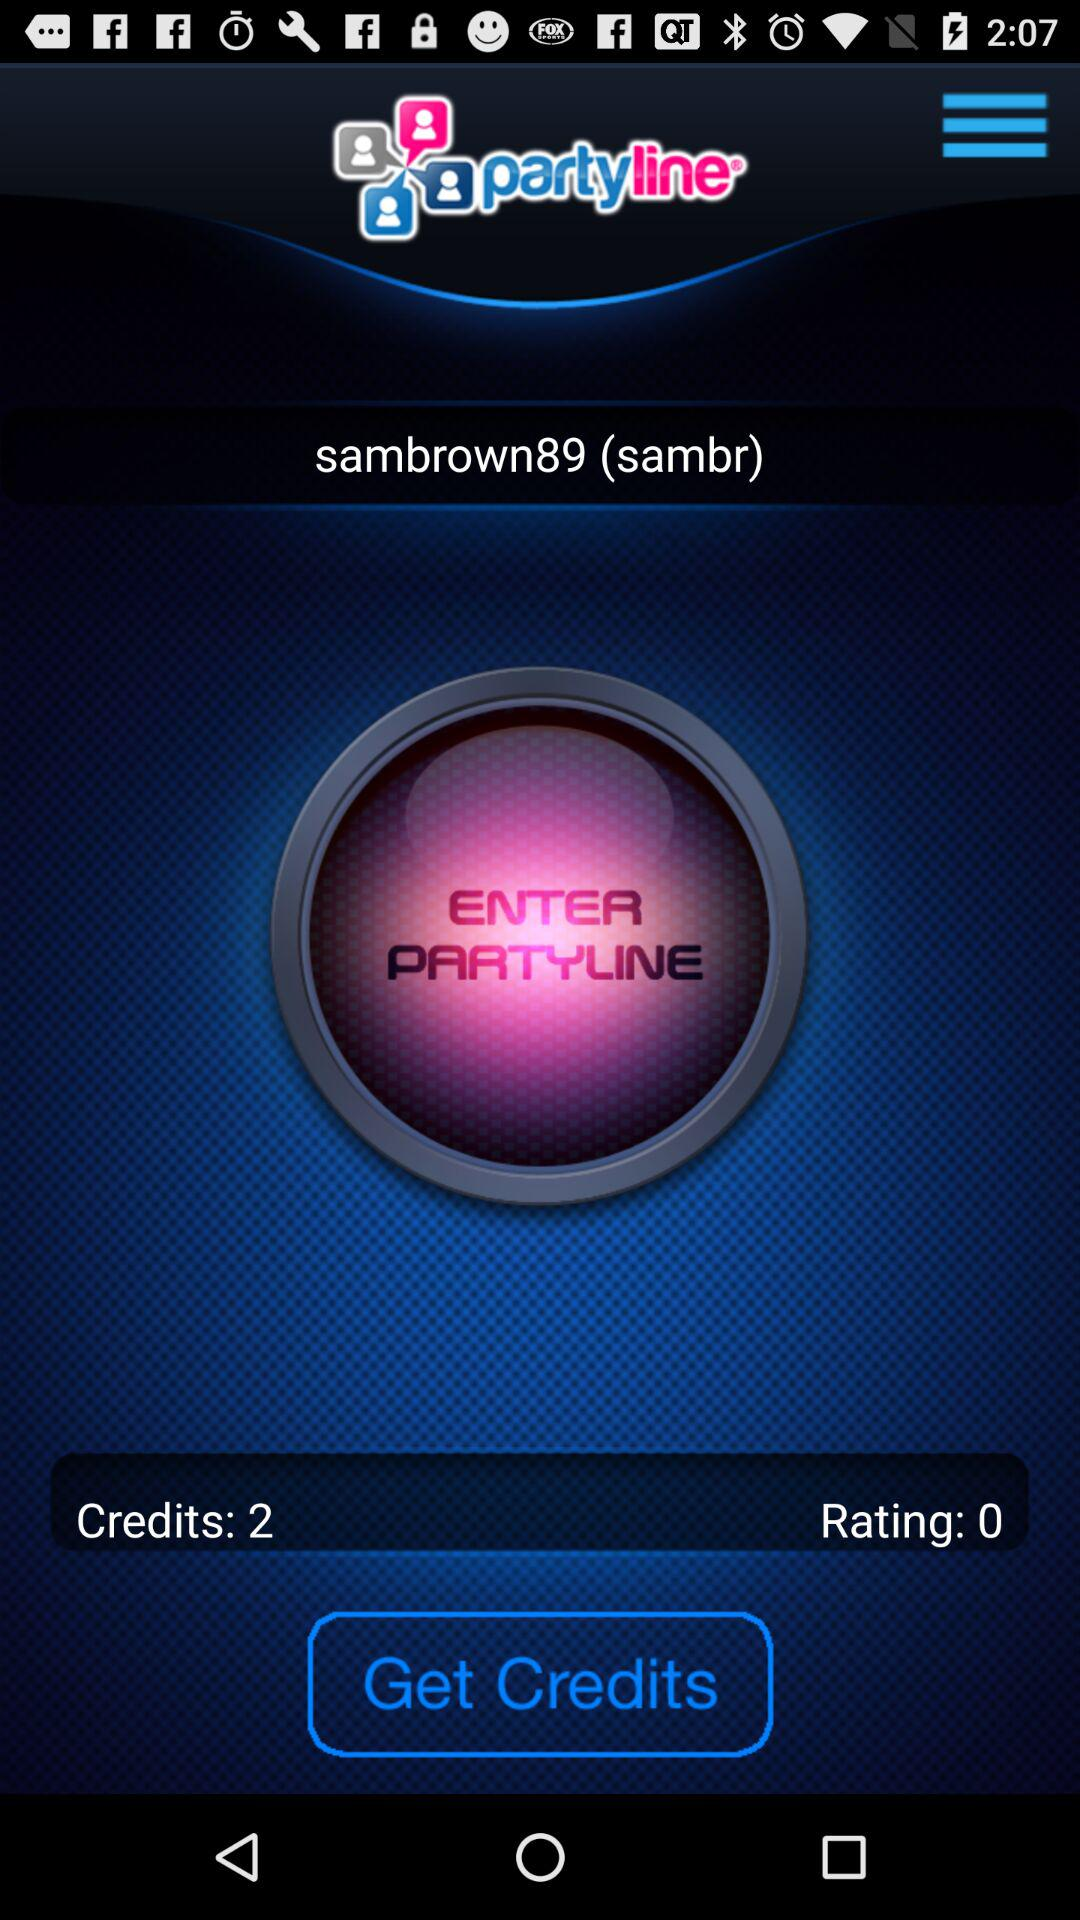How many points are in the credits? There are 2 points in the credit. 